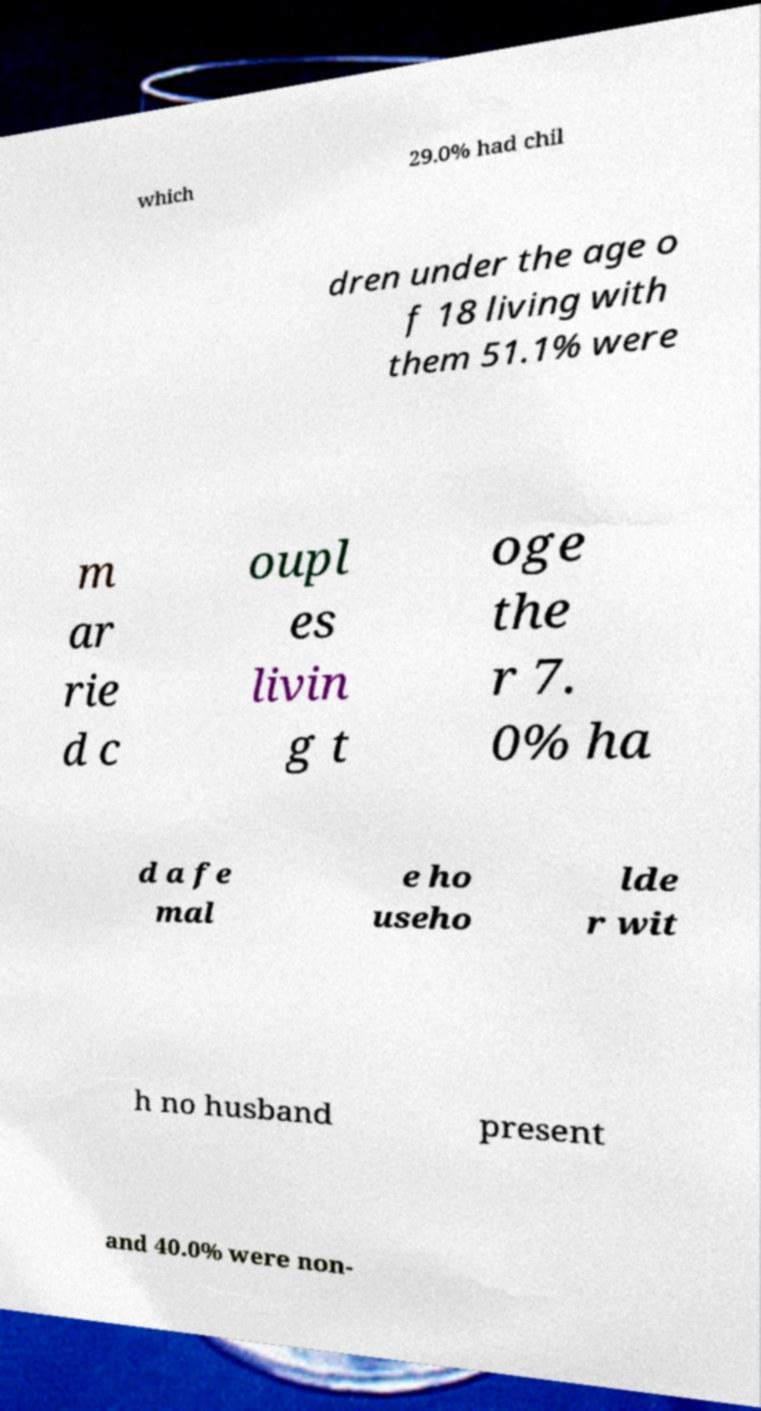Could you extract and type out the text from this image? which 29.0% had chil dren under the age o f 18 living with them 51.1% were m ar rie d c oupl es livin g t oge the r 7. 0% ha d a fe mal e ho useho lde r wit h no husband present and 40.0% were non- 